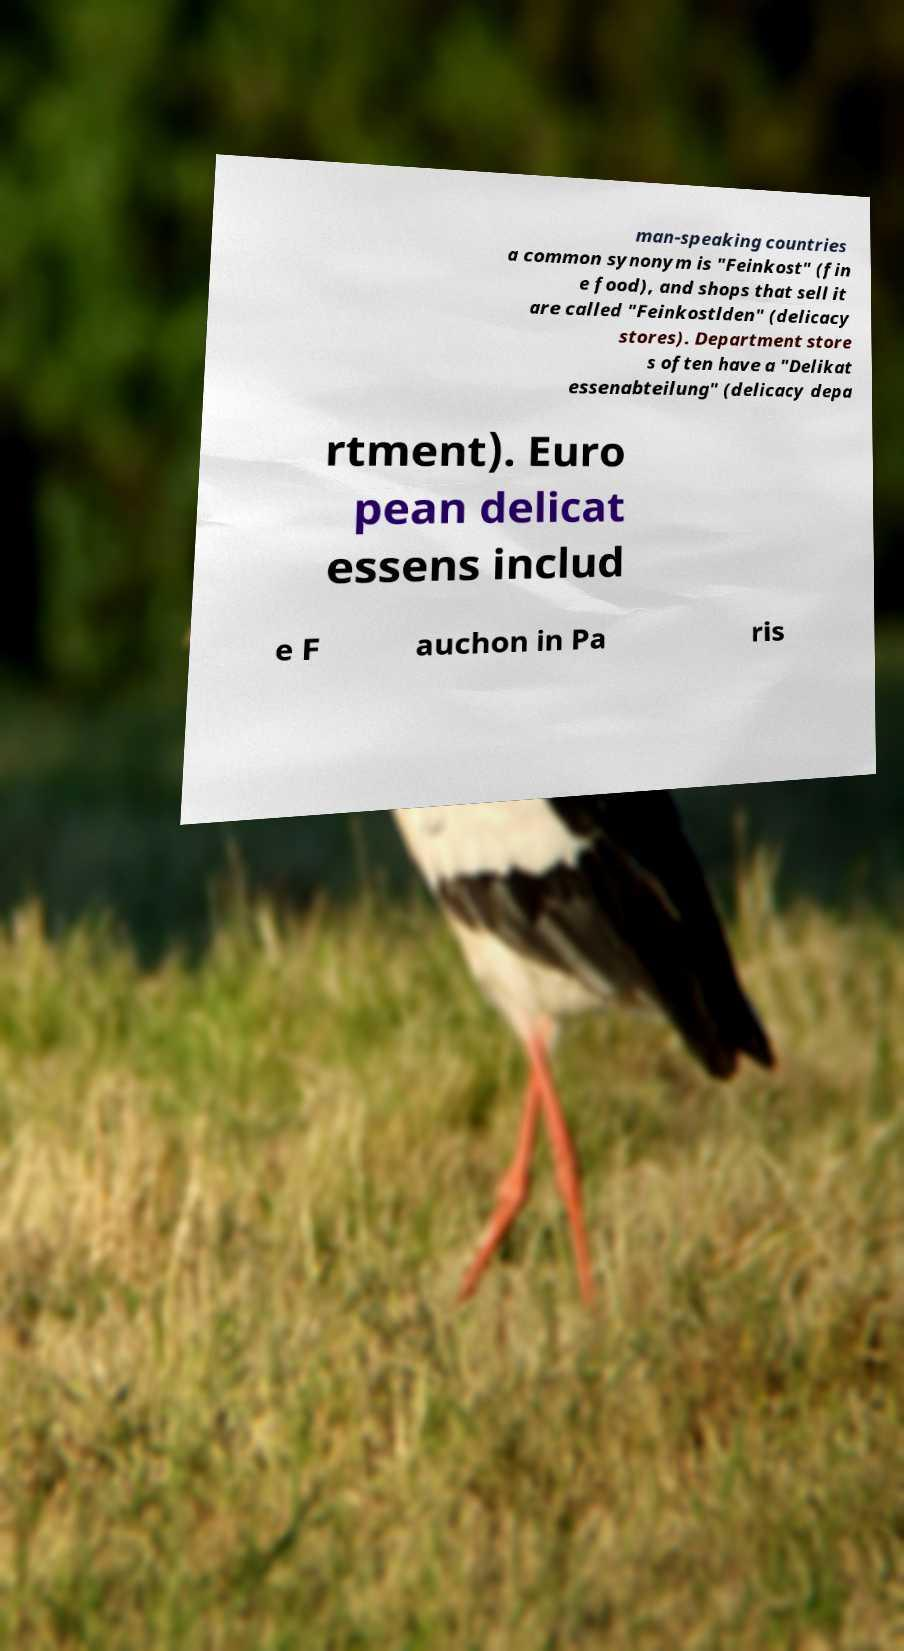Please read and relay the text visible in this image. What does it say? man-speaking countries a common synonym is "Feinkost" (fin e food), and shops that sell it are called "Feinkostlden" (delicacy stores). Department store s often have a "Delikat essenabteilung" (delicacy depa rtment). Euro pean delicat essens includ e F auchon in Pa ris 